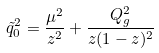<formula> <loc_0><loc_0><loc_500><loc_500>\tilde { q } ^ { 2 } _ { 0 } = \frac { \mu ^ { 2 } } { z ^ { 2 } } + \frac { Q _ { g } ^ { 2 } } { z ( 1 - z ) ^ { 2 } }</formula> 